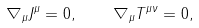Convert formula to latex. <formula><loc_0><loc_0><loc_500><loc_500>\nabla _ { \mu } J ^ { \mu } = 0 , \quad \nabla _ { \mu } T ^ { \mu \nu } = 0 ,</formula> 